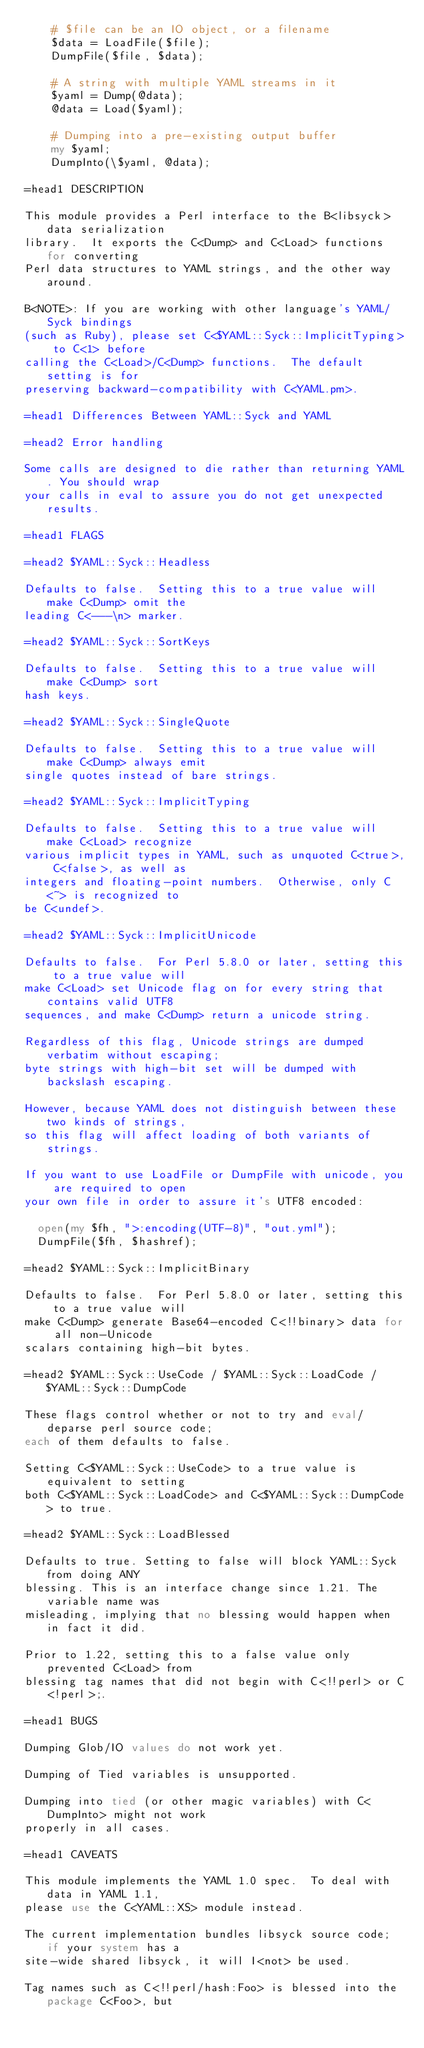<code> <loc_0><loc_0><loc_500><loc_500><_Perl_>    # $file can be an IO object, or a filename
    $data = LoadFile($file);
    DumpFile($file, $data);

    # A string with multiple YAML streams in it
    $yaml = Dump(@data);
    @data = Load($yaml);

    # Dumping into a pre-existing output buffer
    my $yaml;
    DumpInto(\$yaml, @data);

=head1 DESCRIPTION

This module provides a Perl interface to the B<libsyck> data serialization
library.  It exports the C<Dump> and C<Load> functions for converting
Perl data structures to YAML strings, and the other way around.

B<NOTE>: If you are working with other language's YAML/Syck bindings
(such as Ruby), please set C<$YAML::Syck::ImplicitTyping> to C<1> before
calling the C<Load>/C<Dump> functions.  The default setting is for
preserving backward-compatibility with C<YAML.pm>.

=head1 Differences Between YAML::Syck and YAML

=head2 Error handling

Some calls are designed to die rather than returning YAML. You should wrap
your calls in eval to assure you do not get unexpected results.

=head1 FLAGS

=head2 $YAML::Syck::Headless

Defaults to false.  Setting this to a true value will make C<Dump> omit the
leading C<---\n> marker.

=head2 $YAML::Syck::SortKeys

Defaults to false.  Setting this to a true value will make C<Dump> sort
hash keys.

=head2 $YAML::Syck::SingleQuote

Defaults to false.  Setting this to a true value will make C<Dump> always emit
single quotes instead of bare strings.

=head2 $YAML::Syck::ImplicitTyping

Defaults to false.  Setting this to a true value will make C<Load> recognize
various implicit types in YAML, such as unquoted C<true>, C<false>, as well as
integers and floating-point numbers.  Otherwise, only C<~> is recognized to
be C<undef>.

=head2 $YAML::Syck::ImplicitUnicode

Defaults to false.  For Perl 5.8.0 or later, setting this to a true value will
make C<Load> set Unicode flag on for every string that contains valid UTF8
sequences, and make C<Dump> return a unicode string.

Regardless of this flag, Unicode strings are dumped verbatim without escaping;
byte strings with high-bit set will be dumped with backslash escaping.

However, because YAML does not distinguish between these two kinds of strings,
so this flag will affect loading of both variants of strings.

If you want to use LoadFile or DumpFile with unicode, you are required to open
your own file in order to assure it's UTF8 encoded:

  open(my $fh, ">:encoding(UTF-8)", "out.yml");
  DumpFile($fh, $hashref);

=head2 $YAML::Syck::ImplicitBinary

Defaults to false.  For Perl 5.8.0 or later, setting this to a true value will
make C<Dump> generate Base64-encoded C<!!binary> data for all non-Unicode
scalars containing high-bit bytes.

=head2 $YAML::Syck::UseCode / $YAML::Syck::LoadCode / $YAML::Syck::DumpCode

These flags control whether or not to try and eval/deparse perl source code;
each of them defaults to false.

Setting C<$YAML::Syck::UseCode> to a true value is equivalent to setting
both C<$YAML::Syck::LoadCode> and C<$YAML::Syck::DumpCode> to true.

=head2 $YAML::Syck::LoadBlessed

Defaults to true. Setting to false will block YAML::Syck from doing ANY
blessing. This is an interface change since 1.21. The variable name was
misleading, implying that no blessing would happen when in fact it did.

Prior to 1.22, setting this to a false value only prevented C<Load> from
blessing tag names that did not begin with C<!!perl> or C<!perl>;.

=head1 BUGS

Dumping Glob/IO values do not work yet.

Dumping of Tied variables is unsupported.

Dumping into tied (or other magic variables) with C<DumpInto> might not work
properly in all cases.

=head1 CAVEATS

This module implements the YAML 1.0 spec.  To deal with data in YAML 1.1, 
please use the C<YAML::XS> module instead.

The current implementation bundles libsyck source code; if your system has a
site-wide shared libsyck, it will I<not> be used.

Tag names such as C<!!perl/hash:Foo> is blessed into the package C<Foo>, but</code> 